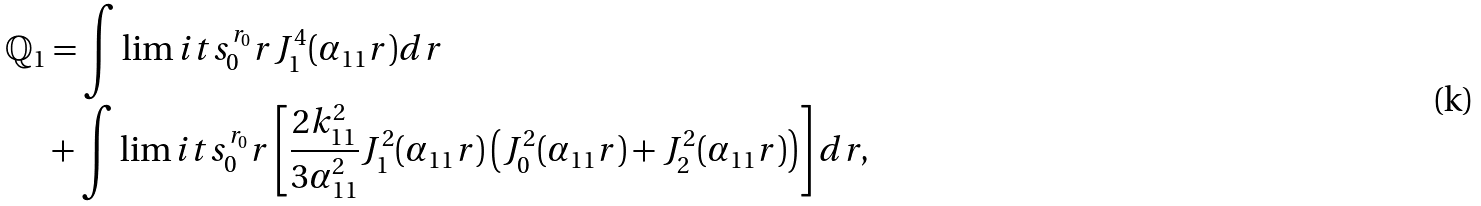<formula> <loc_0><loc_0><loc_500><loc_500>\mathbb { Q } _ { 1 } & = \int \lim i t s _ { 0 } ^ { r _ { 0 } } r J _ { 1 } ^ { 4 } ( \alpha _ { 1 1 } r ) d r \\ & + \int \lim i t s _ { 0 } ^ { r _ { 0 } } r \left [ \frac { 2 k _ { 1 1 } ^ { 2 } } { 3 \alpha _ { 1 1 } ^ { 2 } } J _ { 1 } ^ { 2 } ( \alpha _ { 1 1 } r ) \left ( J _ { 0 } ^ { 2 } ( \alpha _ { 1 1 } r ) + J _ { 2 } ^ { 2 } ( \alpha _ { 1 1 } r ) \right ) \right ] d r ,</formula> 